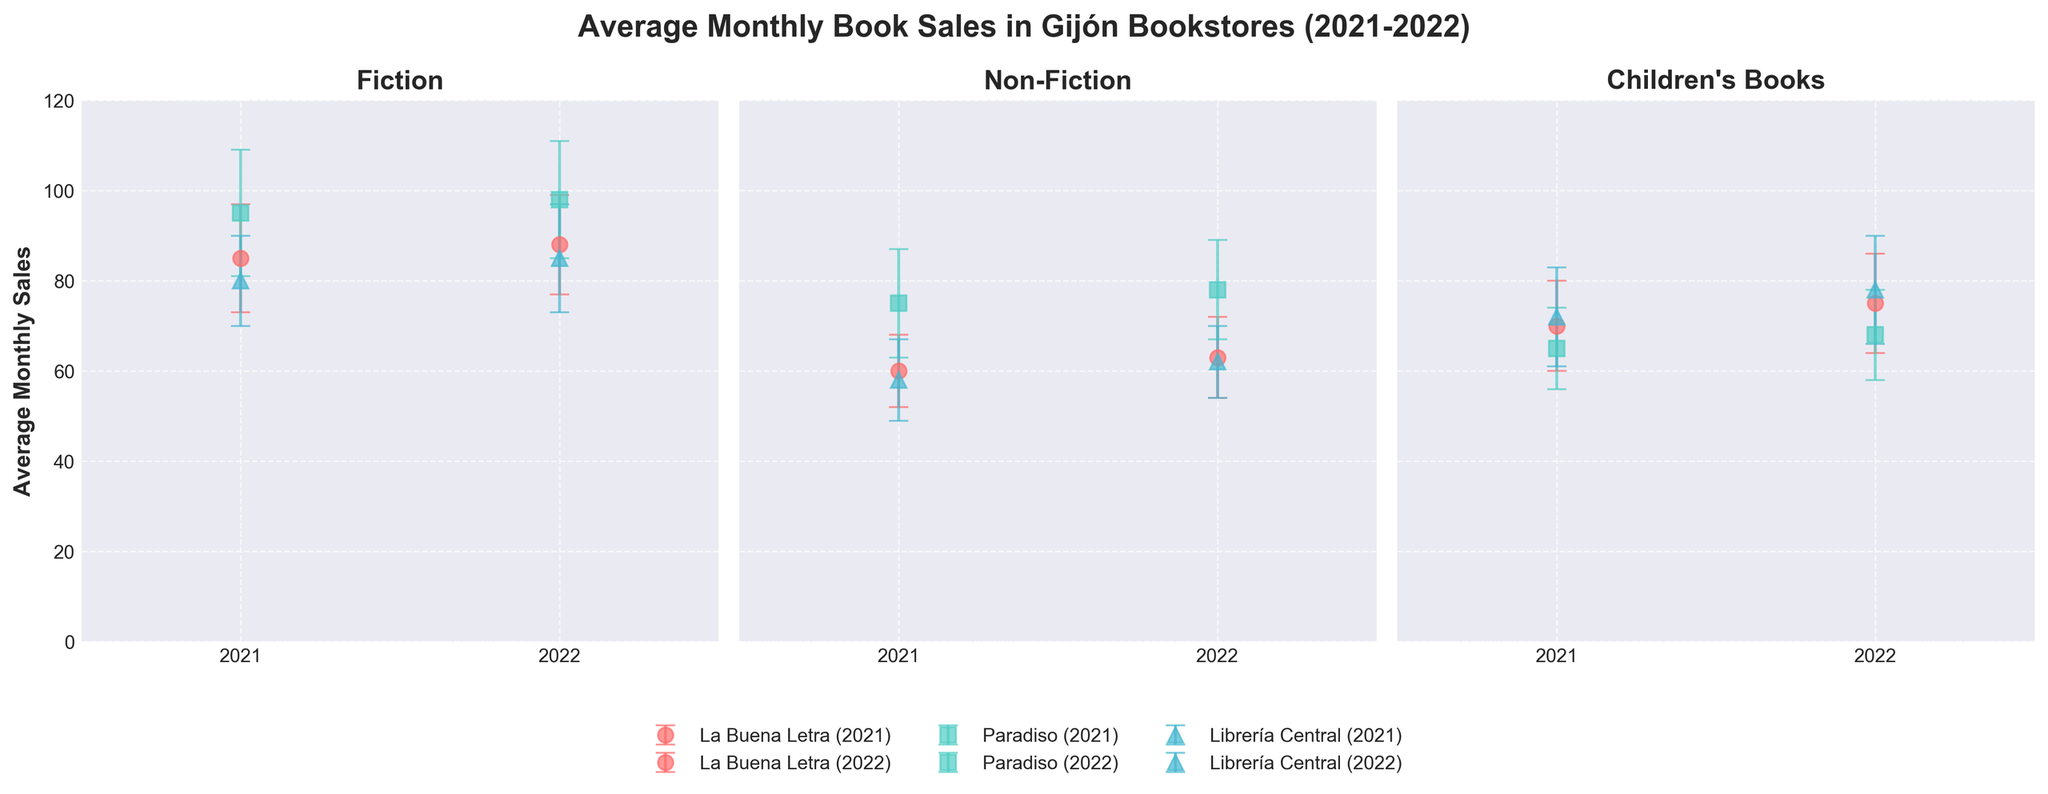What is the title of the entire figure? The title can be found at the top of the figure. It reads, "Average Monthly Book Sales in Gijón Bookstores (2021-2022)"
Answer: Average Monthly Book Sales in Gijón Bookstores (2021-2022) What genres are represented in the figure? The genres are listed as titles at the top of each subplot, which are "Fiction," "Non-Fiction," and "Children's Books."
Answer: Fiction, Non-Fiction, Children's Books Which bookstore had the highest average monthly sales in 2022 for Fiction books? To find the answer, look at the 2022 data points in the Fiction subplot. Paradiso's data point is the highest.
Answer: Paradiso What is the standard deviation of average monthly sales for Children's Books at La Buena Letra in 2021? Locate the data point for La Buena Letra in the Children's Books subplot for the year 2021. The error bar indicates the standard deviation, which in this case is noted as 10.
Answer: 10 Did average monthly sales for Non-Fiction at Librería Central increase or decrease from 2021 to 2022? Compare the 2021 to 2022 data points for Non-Fiction at Librería Central. The average monthly sales increased from 58 to 62.
Answer: Increase Which genre had the smallest increase in average monthly sales at La Buena Letra from 2021 to 2022? Calculate the difference in average monthly sales for each genre at La Buena Letra. Fiction increased by 3, Non-Fiction by 3, and Children's Books by 5. Both Fiction and Non-Fiction have the smallest increase.
Answer: Fiction and Non-Fiction How many bookstores are represented in each subplot? Each subplot includes data points for La Buena Letra, Paradiso, and Librería Central. There are 3 bookstores represented in each genre subplot.
Answer: 3 Which bookstore had the highest standard deviation in average monthly sales for Fiction books in 2021? Examine the error bars for Fiction in 2021; Paradiso has the highest standard deviation at 14.
Answer: Paradiso By how much did the average monthly sales for Children's Books at Paradiso change from 2021 to 2022? For Children's Books in Paradiso, subtract the 2021 value (65) from the 2022 value (68). The change is 68 - 65 = 3.
Answer: 3 